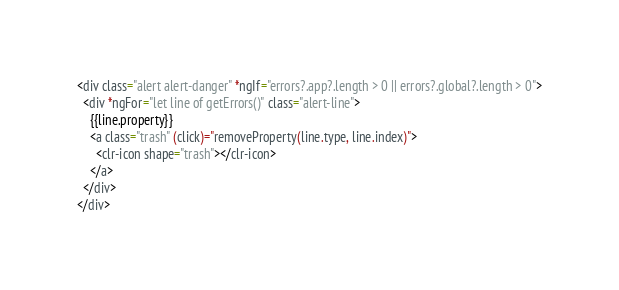<code> <loc_0><loc_0><loc_500><loc_500><_HTML_><div class="alert alert-danger" *ngIf="errors?.app?.length > 0 || errors?.global?.length > 0">
  <div *ngFor="let line of getErrors()" class="alert-line">
    {{line.property}}
    <a class="trash" (click)="removeProperty(line.type, line.index)">
      <clr-icon shape="trash"></clr-icon>
    </a>
  </div>
</div>
</code> 